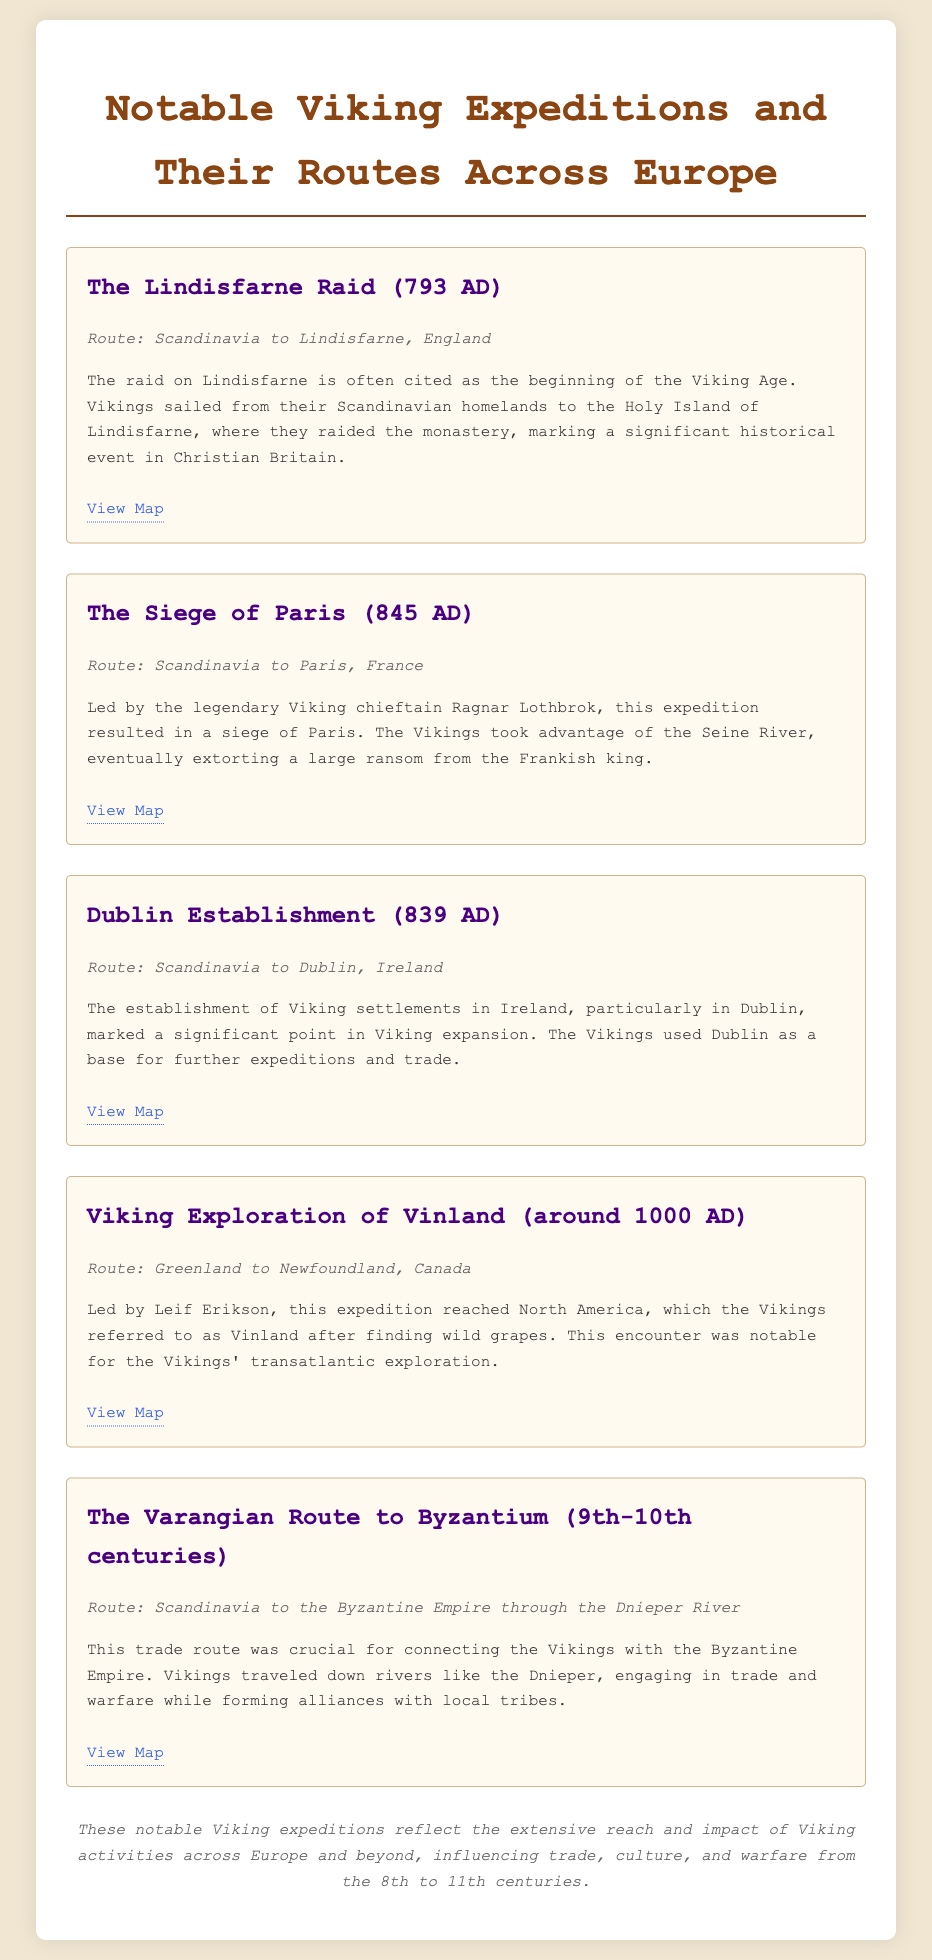What year did the Lindisfarne Raid occur? The Lindisfarne Raid is dated to 793 AD as mentioned in the description of the expedition.
Answer: 793 AD Who led the Siege of Paris? The expedition was led by the legendary Viking chieftain Ragnar Lothbrok, as stated in the description.
Answer: Ragnar Lothbrok What was the route of the Viking exploration of Vinland? The document describes the route as Greenland to Newfoundland, Canada for the Vinland exploration.
Answer: Greenland to Newfoundland, Canada Which city was established as a Viking settlement in Ireland? The document notes that Vikings established Dublin as a settlement in Ireland.
Answer: Dublin What was the significance of the Varangian Route? The Varangian Route is described as crucial for connecting the Vikings with the Byzantine Empire through trade and alliances.
Answer: Connecting with the Byzantine Empire What major event does the Lindisfarne Raid signify? The text states that the raid is often cited as the beginning of the Viking Age.
Answer: Beginning of the Viking Age In what centuries did the Varangian Route activities occur? The document specifies that the Varangian Route activities took place in the 9th-10th centuries.
Answer: 9th-10th centuries What natural feature did the Vikings utilize during the Siege of Paris? The description mentions that the Vikings took advantage of the Seine River during the siege.
Answer: Seine River 